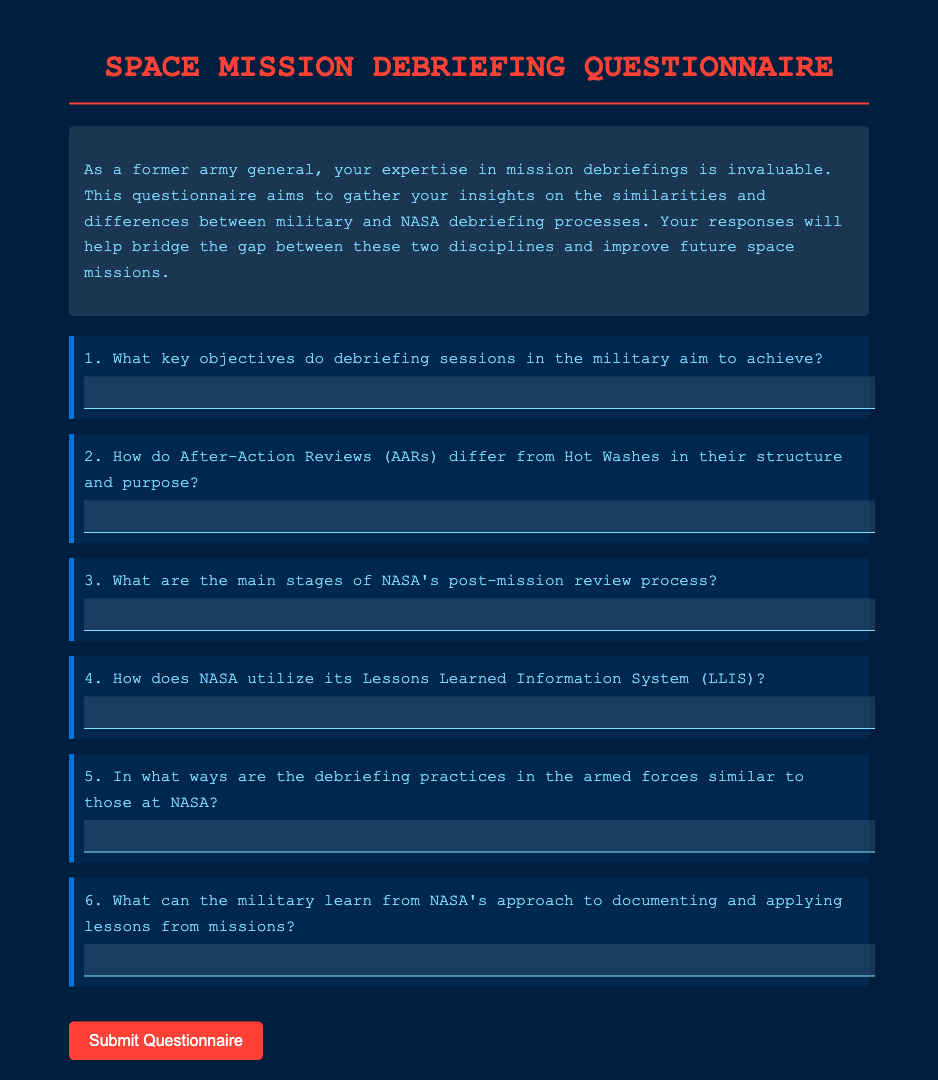What is the title of the document? The title is prominently displayed at the top of the document, indicating the subject matter.
Answer: Space Mission Debriefing Questionnaire How many main questions are in the questionnaire? The document outlines concise questions, and counting them gives the total number of main questions.
Answer: 6 What is the primary color used for headings in the document? The color of headings is specified in the styles section and can be identified visually in the document.
Answer: Red What is the purpose of the questionnaire? The purpose is stated in the introductory paragraph and provides insight into the questionnaire's aim.
Answer: Gather insights What does AAR stand for in a military context? The acronym is commonly mentioned in military circles and is defined in context to further understanding of the debriefing methods.
Answer: After-Action Review What is a significant tool used by NASA for lessons learned? The document mentions a specific system utilized by NASA for documenting useful insights.
Answer: Lessons Learned Information System (LLIS) 